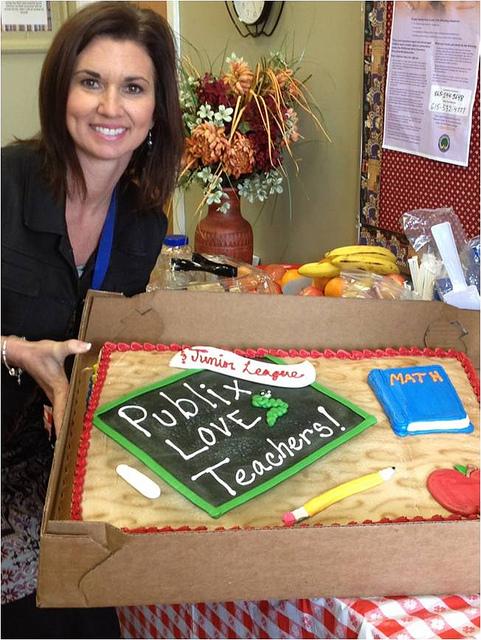Who loves teachers?
Short answer required. Publix. Who likely made this cake?
Write a very short answer. Publix. What color is the book on the cake?
Give a very brief answer. Blue. 